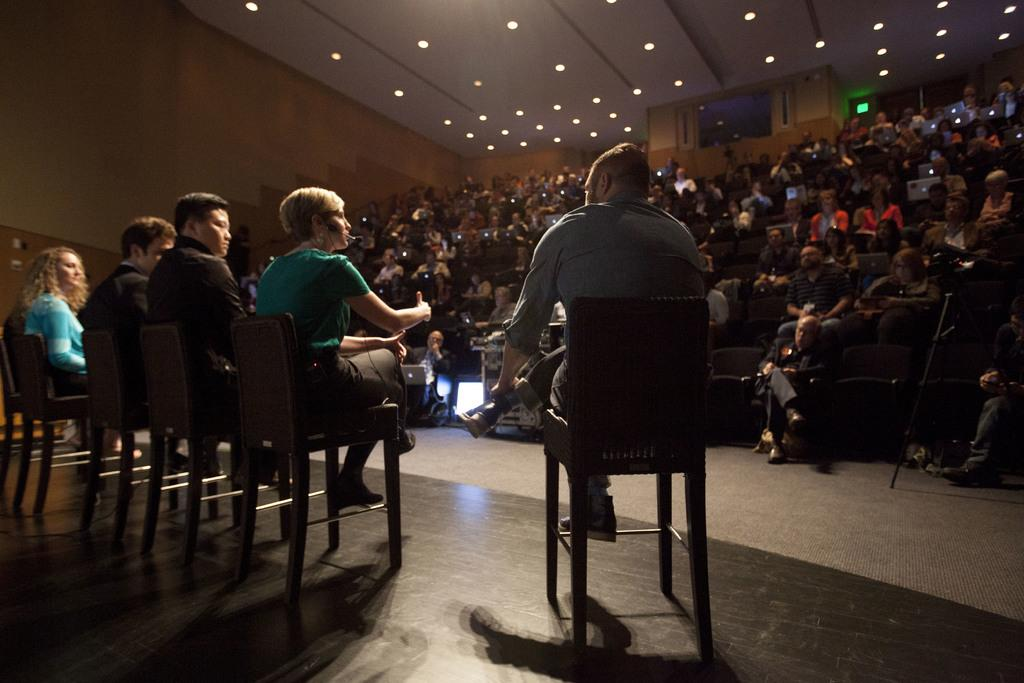What is the main subject of the image? The main subject of the image is a group of people. What are the people doing in the image? The people are sitting on chairs in the image. Are any objects being held by the people? Yes, some people are holding laptops in the image. What can be seen in the background of the image? There are lights visible in the background of the image. What type of pipe is being used by the people in the image? There is no pipe present in the image. Can you tell me how many pets are visible in the image? There are no pets visible in the image. 